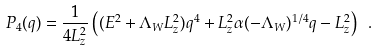<formula> <loc_0><loc_0><loc_500><loc_500>P _ { 4 } ( q ) = \frac { 1 } { 4 L _ { z } ^ { 2 } } \left ( ( E ^ { 2 } + \Lambda _ { W } L _ { z } ^ { 2 } ) q ^ { 4 } + L _ { z } ^ { 2 } \alpha ( - \Lambda _ { W } ) ^ { 1 / 4 } q - L _ { z } ^ { 2 } \right ) \ .</formula> 